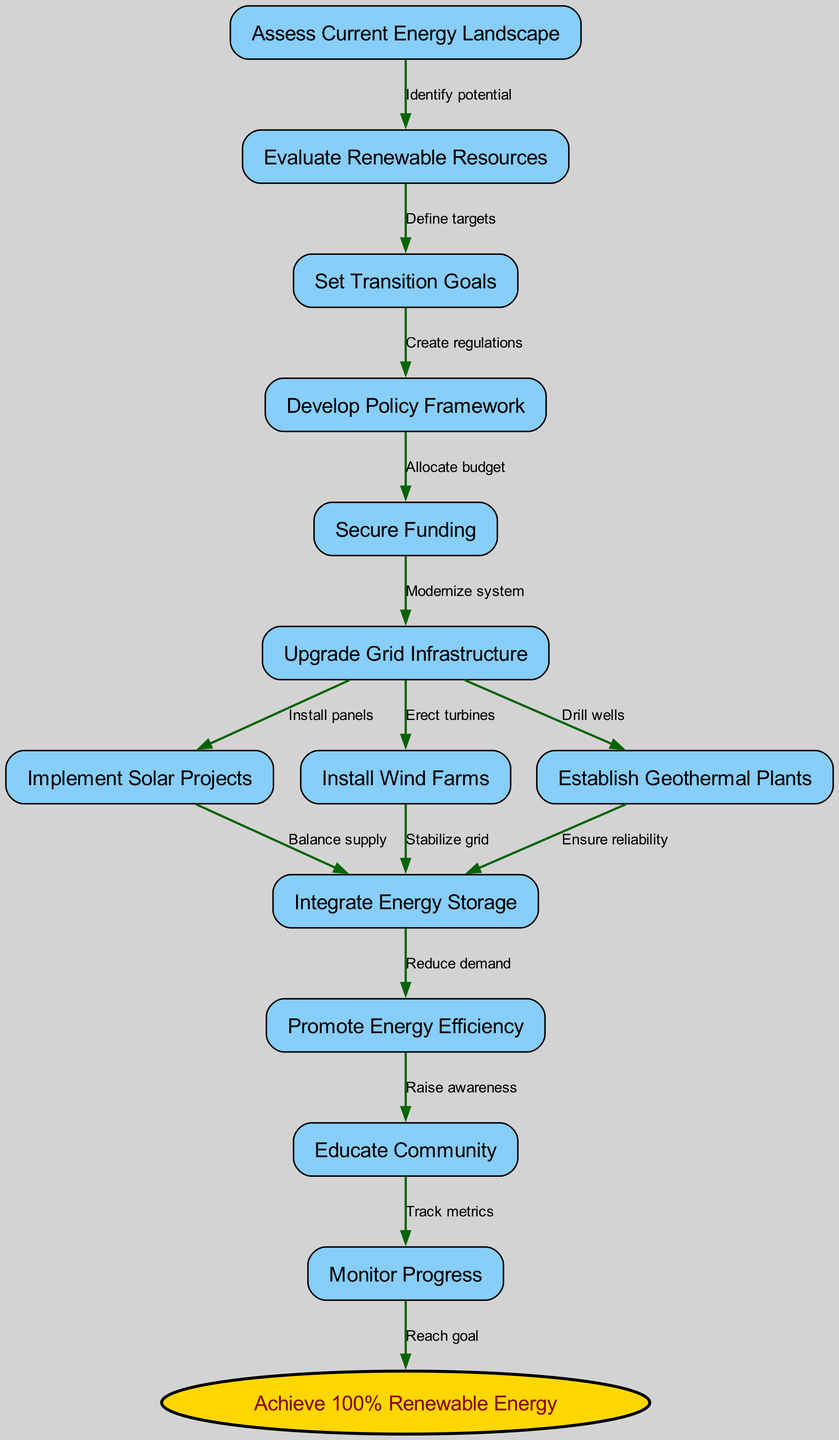What is the starting node of the diagram? The starting node is the first element of the flowchart process. According to the data provided, the starting node listed is "Assess Current Energy Landscape".
Answer: Assess Current Energy Landscape How many nodes are present in the flowchart? To find the count of nodes, I can count the items listed under "nodes". There are 13 unique nodes mentioned, including the starting node.
Answer: 13 What action follows after "Secure Funding"? The edge originating from "Secure Funding" points to "Upgrade Grid Infrastructure", indicating this is the next step in the process.
Answer: Upgrade Grid Infrastructure What is the last node in the flowchart? The final node, indicating the goal of this transition process, is specifically mentioned in the data as "Achieve 100% Renewable Energy".
Answer: Achieve 100% Renewable Energy Which two nodes are directly connected to "Upgrade Grid Infrastructure"? "Upgrade Grid Infrastructure" has three outgoing edges towards "Implement Solar Projects", "Install Wind Farms", and "Establish Geothermal Plants". Therefore, the nodes directly connected are "Implement Solar Projects" and "Install Wind Farms".
Answer: Implement Solar Projects and Install Wind Farms What is the flow of action starting from "Educate Community"? The flow starting from "Educate Community" leads to "Monitor Progress", which means the outcome of educating the community is to then monitor the processes they are involved in post-education.
Answer: Monitor Progress Which stage involves balancing the supply of generated energy? The step that involves balancing the supply occurs right after implementing solar projects and before promoting energy efficiency, specifically within "Integrate Energy Storage".
Answer: Integrate Energy Storage Explain the relationship between "Promote Energy Efficiency" and "Educate Community". "Promote Energy Efficiency" results in raising awareness about energy-saving practices, which is detailed in the edge direction from "Promote Energy Efficiency" pointing to "Educate Community". This shows that the promotion leads directly to community education efforts.
Answer: Raise awareness What step is necessary before implementing renewable energy projects? To move forward with implementing renewable energy projects, securing funding is essential. This step of obtaining financial support is critical for the subsequent stages.
Answer: Secure Funding 